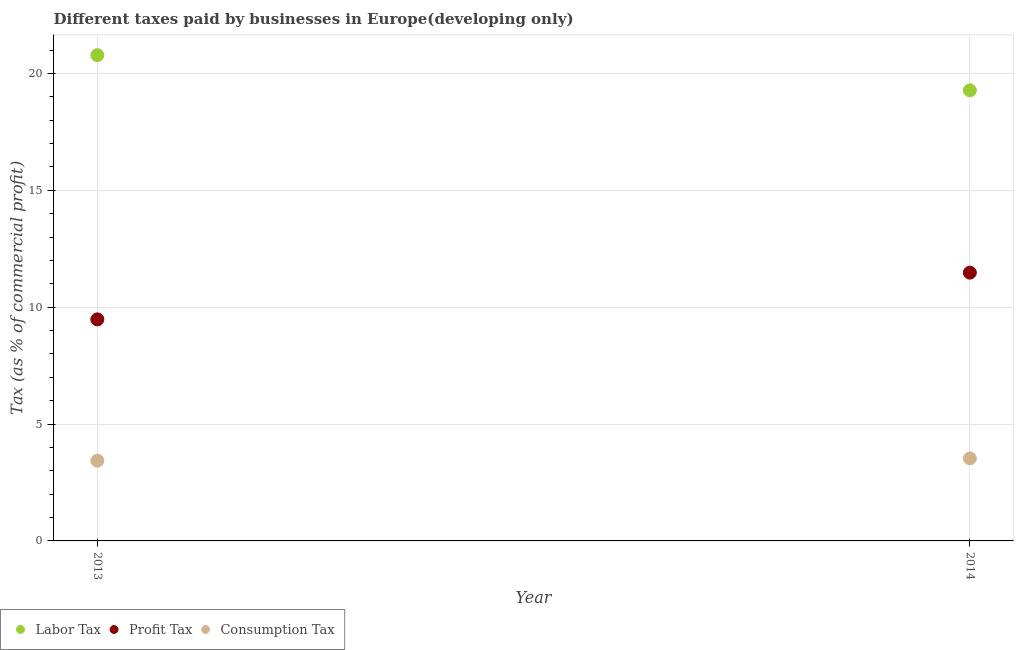Is the number of dotlines equal to the number of legend labels?
Offer a terse response. Yes. What is the percentage of consumption tax in 2014?
Offer a terse response. 3.53. Across all years, what is the maximum percentage of consumption tax?
Provide a short and direct response. 3.53. Across all years, what is the minimum percentage of labor tax?
Offer a very short reply. 19.28. In which year was the percentage of profit tax maximum?
Provide a succinct answer. 2014. In which year was the percentage of consumption tax minimum?
Ensure brevity in your answer.  2013. What is the total percentage of consumption tax in the graph?
Your answer should be compact. 6.96. What is the difference between the percentage of profit tax in 2013 and that in 2014?
Your answer should be very brief. -2. What is the difference between the percentage of labor tax in 2014 and the percentage of consumption tax in 2013?
Give a very brief answer. 15.85. What is the average percentage of profit tax per year?
Provide a short and direct response. 10.48. In the year 2013, what is the difference between the percentage of labor tax and percentage of consumption tax?
Give a very brief answer. 17.35. What is the ratio of the percentage of consumption tax in 2013 to that in 2014?
Give a very brief answer. 0.97. Is it the case that in every year, the sum of the percentage of labor tax and percentage of profit tax is greater than the percentage of consumption tax?
Provide a short and direct response. Yes. Is the percentage of labor tax strictly greater than the percentage of consumption tax over the years?
Your answer should be very brief. Yes. How many dotlines are there?
Your response must be concise. 3. How many years are there in the graph?
Your answer should be compact. 2. What is the difference between two consecutive major ticks on the Y-axis?
Give a very brief answer. 5. Are the values on the major ticks of Y-axis written in scientific E-notation?
Offer a very short reply. No. Does the graph contain any zero values?
Keep it short and to the point. No. Does the graph contain grids?
Offer a very short reply. Yes. Where does the legend appear in the graph?
Your answer should be compact. Bottom left. How many legend labels are there?
Give a very brief answer. 3. How are the legend labels stacked?
Provide a succinct answer. Horizontal. What is the title of the graph?
Offer a very short reply. Different taxes paid by businesses in Europe(developing only). What is the label or title of the Y-axis?
Provide a succinct answer. Tax (as % of commercial profit). What is the Tax (as % of commercial profit) of Labor Tax in 2013?
Give a very brief answer. 20.78. What is the Tax (as % of commercial profit) of Profit Tax in 2013?
Ensure brevity in your answer.  9.48. What is the Tax (as % of commercial profit) of Consumption Tax in 2013?
Ensure brevity in your answer.  3.43. What is the Tax (as % of commercial profit) in Labor Tax in 2014?
Provide a succinct answer. 19.28. What is the Tax (as % of commercial profit) in Profit Tax in 2014?
Your answer should be compact. 11.48. What is the Tax (as % of commercial profit) in Consumption Tax in 2014?
Ensure brevity in your answer.  3.53. Across all years, what is the maximum Tax (as % of commercial profit) of Labor Tax?
Provide a succinct answer. 20.78. Across all years, what is the maximum Tax (as % of commercial profit) of Profit Tax?
Keep it short and to the point. 11.48. Across all years, what is the maximum Tax (as % of commercial profit) in Consumption Tax?
Keep it short and to the point. 3.53. Across all years, what is the minimum Tax (as % of commercial profit) of Labor Tax?
Provide a short and direct response. 19.28. Across all years, what is the minimum Tax (as % of commercial profit) in Profit Tax?
Your response must be concise. 9.48. Across all years, what is the minimum Tax (as % of commercial profit) of Consumption Tax?
Ensure brevity in your answer.  3.43. What is the total Tax (as % of commercial profit) of Labor Tax in the graph?
Offer a terse response. 40.06. What is the total Tax (as % of commercial profit) in Profit Tax in the graph?
Keep it short and to the point. 20.96. What is the total Tax (as % of commercial profit) of Consumption Tax in the graph?
Your response must be concise. 6.96. What is the difference between the Tax (as % of commercial profit) in Labor Tax in 2013 and that in 2014?
Provide a short and direct response. 1.51. What is the difference between the Tax (as % of commercial profit) of Labor Tax in 2013 and the Tax (as % of commercial profit) of Profit Tax in 2014?
Offer a very short reply. 9.31. What is the difference between the Tax (as % of commercial profit) of Labor Tax in 2013 and the Tax (as % of commercial profit) of Consumption Tax in 2014?
Your response must be concise. 17.25. What is the difference between the Tax (as % of commercial profit) of Profit Tax in 2013 and the Tax (as % of commercial profit) of Consumption Tax in 2014?
Ensure brevity in your answer.  5.95. What is the average Tax (as % of commercial profit) of Labor Tax per year?
Offer a terse response. 20.03. What is the average Tax (as % of commercial profit) of Profit Tax per year?
Give a very brief answer. 10.48. What is the average Tax (as % of commercial profit) of Consumption Tax per year?
Your response must be concise. 3.48. In the year 2013, what is the difference between the Tax (as % of commercial profit) of Labor Tax and Tax (as % of commercial profit) of Profit Tax?
Provide a short and direct response. 11.31. In the year 2013, what is the difference between the Tax (as % of commercial profit) in Labor Tax and Tax (as % of commercial profit) in Consumption Tax?
Ensure brevity in your answer.  17.35. In the year 2013, what is the difference between the Tax (as % of commercial profit) in Profit Tax and Tax (as % of commercial profit) in Consumption Tax?
Your response must be concise. 6.05. In the year 2014, what is the difference between the Tax (as % of commercial profit) of Labor Tax and Tax (as % of commercial profit) of Profit Tax?
Ensure brevity in your answer.  7.8. In the year 2014, what is the difference between the Tax (as % of commercial profit) of Labor Tax and Tax (as % of commercial profit) of Consumption Tax?
Ensure brevity in your answer.  15.75. In the year 2014, what is the difference between the Tax (as % of commercial profit) in Profit Tax and Tax (as % of commercial profit) in Consumption Tax?
Provide a succinct answer. 7.95. What is the ratio of the Tax (as % of commercial profit) of Labor Tax in 2013 to that in 2014?
Keep it short and to the point. 1.08. What is the ratio of the Tax (as % of commercial profit) in Profit Tax in 2013 to that in 2014?
Keep it short and to the point. 0.83. What is the ratio of the Tax (as % of commercial profit) in Consumption Tax in 2013 to that in 2014?
Keep it short and to the point. 0.97. What is the difference between the highest and the second highest Tax (as % of commercial profit) in Labor Tax?
Ensure brevity in your answer.  1.51. What is the difference between the highest and the second highest Tax (as % of commercial profit) in Consumption Tax?
Your answer should be very brief. 0.1. What is the difference between the highest and the lowest Tax (as % of commercial profit) of Labor Tax?
Your response must be concise. 1.51. What is the difference between the highest and the lowest Tax (as % of commercial profit) in Consumption Tax?
Your response must be concise. 0.1. 